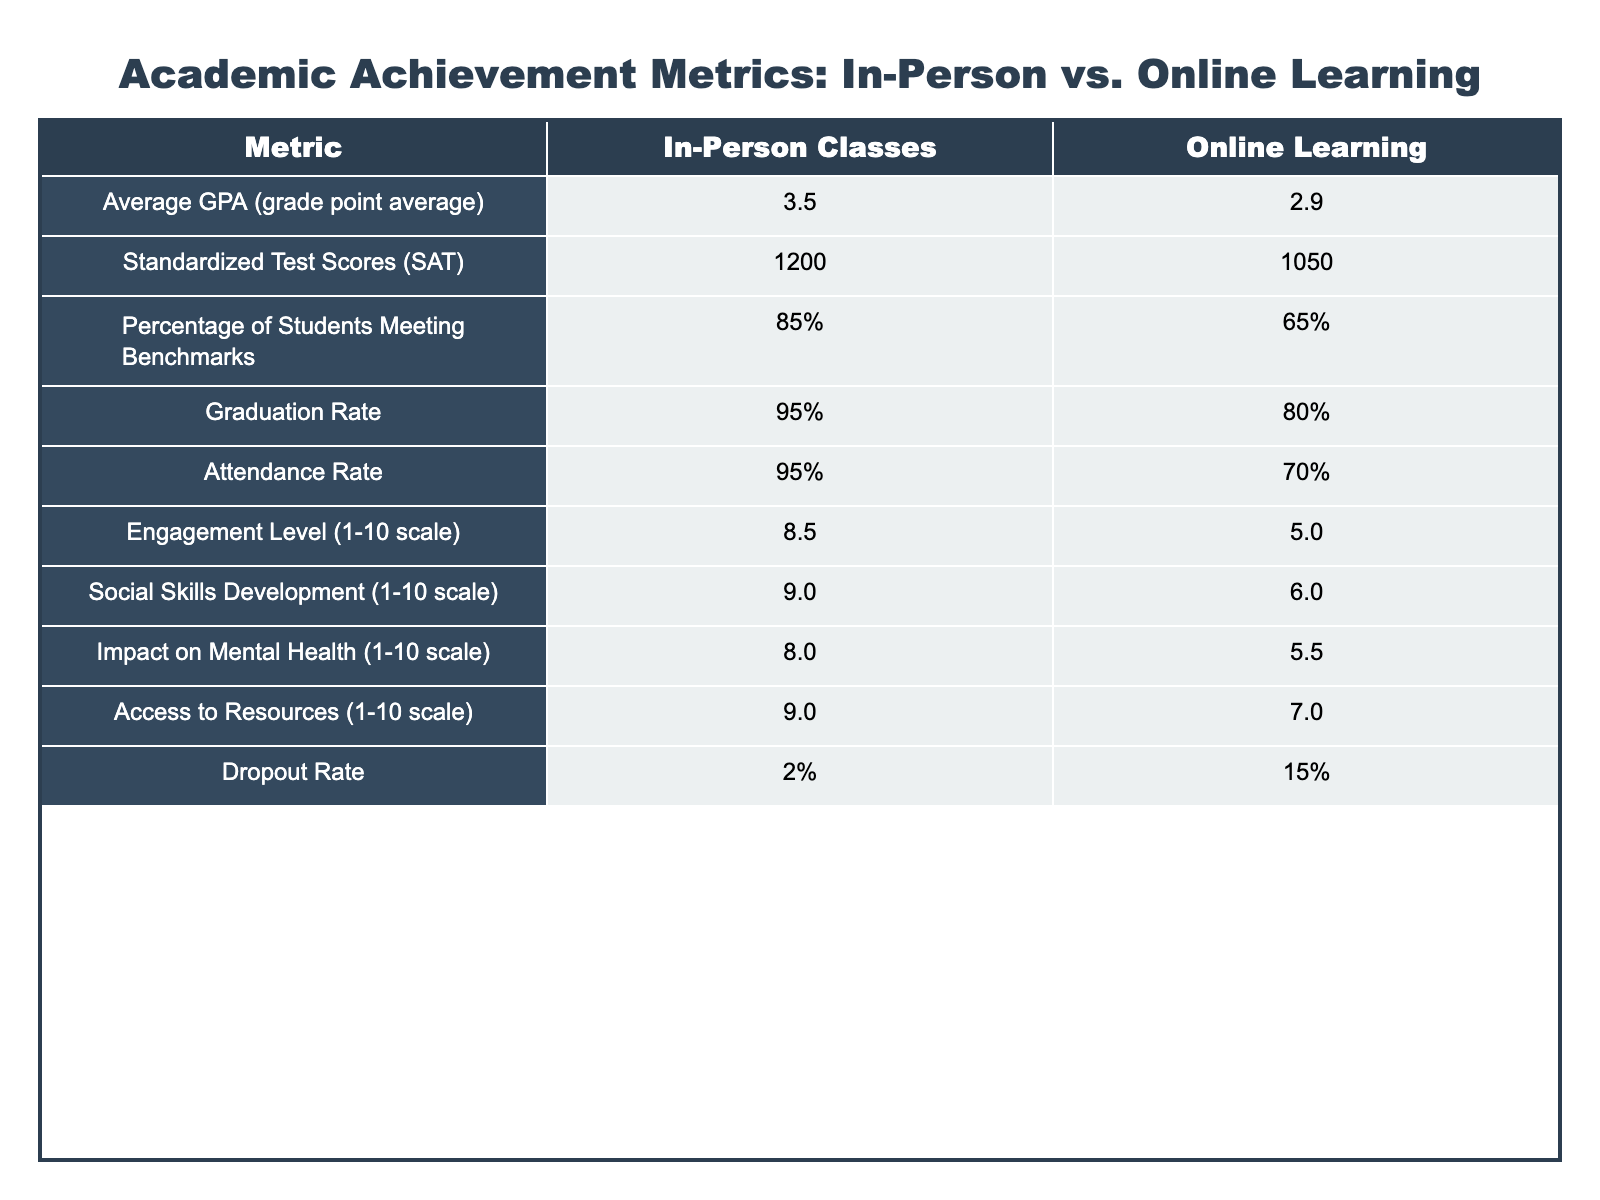What is the average GPA for students in in-person classes? The table shows that the average GPA for students in in-person classes is listed as 3.5.
Answer: 3.5 What is the standardized test score difference between in-person classes and online learning? The average score for in-person classes is 1200, and for online learning, it's 1050. The difference is 1200 - 1050 = 150.
Answer: 150 What percentage of students in online learning meet academic benchmarks? According to the table, 65% of students in online learning meet academic benchmarks.
Answer: 65% Is the graduation rate for students in in-person classes higher than that of online learners? The graduation rate for in-person classes is 95%, while for online learners, it is 80%. Since 95% is greater than 80%, the claim is true.
Answer: Yes What is the attendance rate for online learning? The table indicates that the attendance rate for online learning is 70%.
Answer: 70% How does the engagement level compare between the two learning formats? The engagement level is rated as 8.5 for in-person classes and 5.0 for online learning. The difference is 8.5 - 5.0 = 3.5, showing that in-person classes have a significantly higher engagement level.
Answer: 3.5 What percentage of students drop out from online learning compared to in-person classes? The dropout rate is 15% for online learning and 2% for in-person classes. The difference is 15% - 2% = 13%, indicating a much higher dropout rate for online learning.
Answer: 13% Are students' social skills development scores higher in in-person classes or online learning? The table shows a social skills development score of 9.0 for in-person classes and 6.0 for online learning. Since 9.0 is greater than 6.0, students in in-person classes have higher scores.
Answer: In-person classes What is the overall difference in access to resources between in-person classes and online learning? In-person classes have an access to resources score of 9.0, and online learning has a score of 7.0. The difference is 9.0 - 7.0 = 2.0.
Answer: 2.0 What can be inferred about the mental health impact of in-person classes versus online learning? The mental health impact score for in-person classes is 8.0, while for online learning, it is 5.5. Since 8.0 is higher, it can be inferred that in-person classes have a more positive impact on mental health.
Answer: Positive impact for in-person classes 